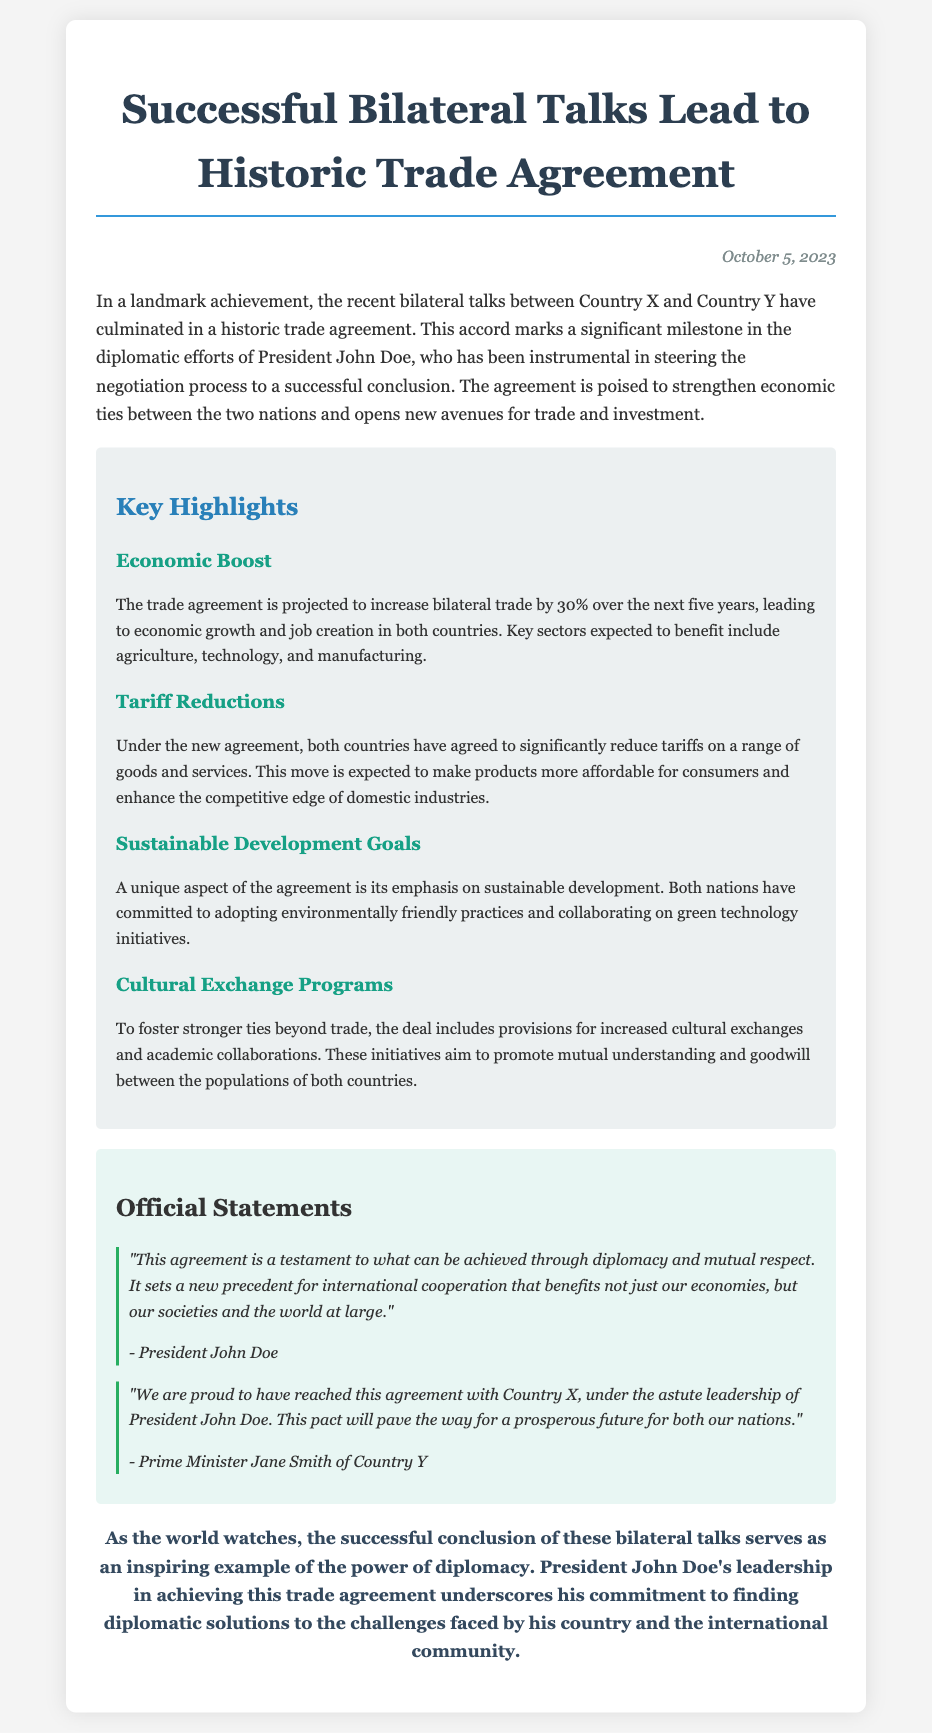What is the date of the press release? The date is stated at the top right corner of the document.
Answer: October 5, 2023 Who is the President mentioned in the document? The President's name is mentioned in the introduction of the document.
Answer: John Doe What is the projected increase in bilateral trade? The increase in bilateral trade is mentioned in the key highlights section.
Answer: 30% What sectors are expected to benefit from the trade agreement? The sectors are listed in the highlight about economic boost.
Answer: Agriculture, technology, and manufacturing What unique aspect is emphasized in the agreement? The unique aspect is highlighted in the section about sustainable development goals.
Answer: Sustainable development Who provided an official statement alongside President John Doe? The other official is mentioned in the official statements section.
Answer: Prime Minister Jane Smith What does the trade agreement aim to enhance? This aim is stated in the highlight about tariff reductions.
Answer: Competitive edge of domestic industries What is included in the deal to foster stronger ties? The deal encompasses specific initiatives to strengthen relationships which are outlined in a highlight.
Answer: Cultural exchange programs 